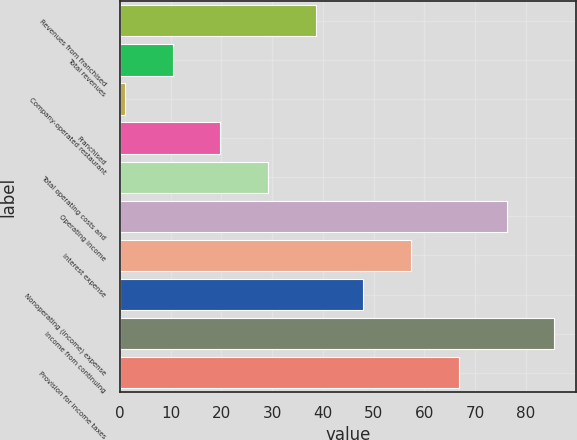<chart> <loc_0><loc_0><loc_500><loc_500><bar_chart><fcel>Revenues from franchised<fcel>Total revenues<fcel>Company-operated restaurant<fcel>Franchised<fcel>Total operating costs and<fcel>Operating income<fcel>Interest expense<fcel>Nonoperating (income) expense<fcel>Income from continuing<fcel>Provision for income taxes<nl><fcel>38.6<fcel>10.4<fcel>1<fcel>19.8<fcel>29.2<fcel>76.2<fcel>57.4<fcel>48<fcel>85.6<fcel>66.8<nl></chart> 